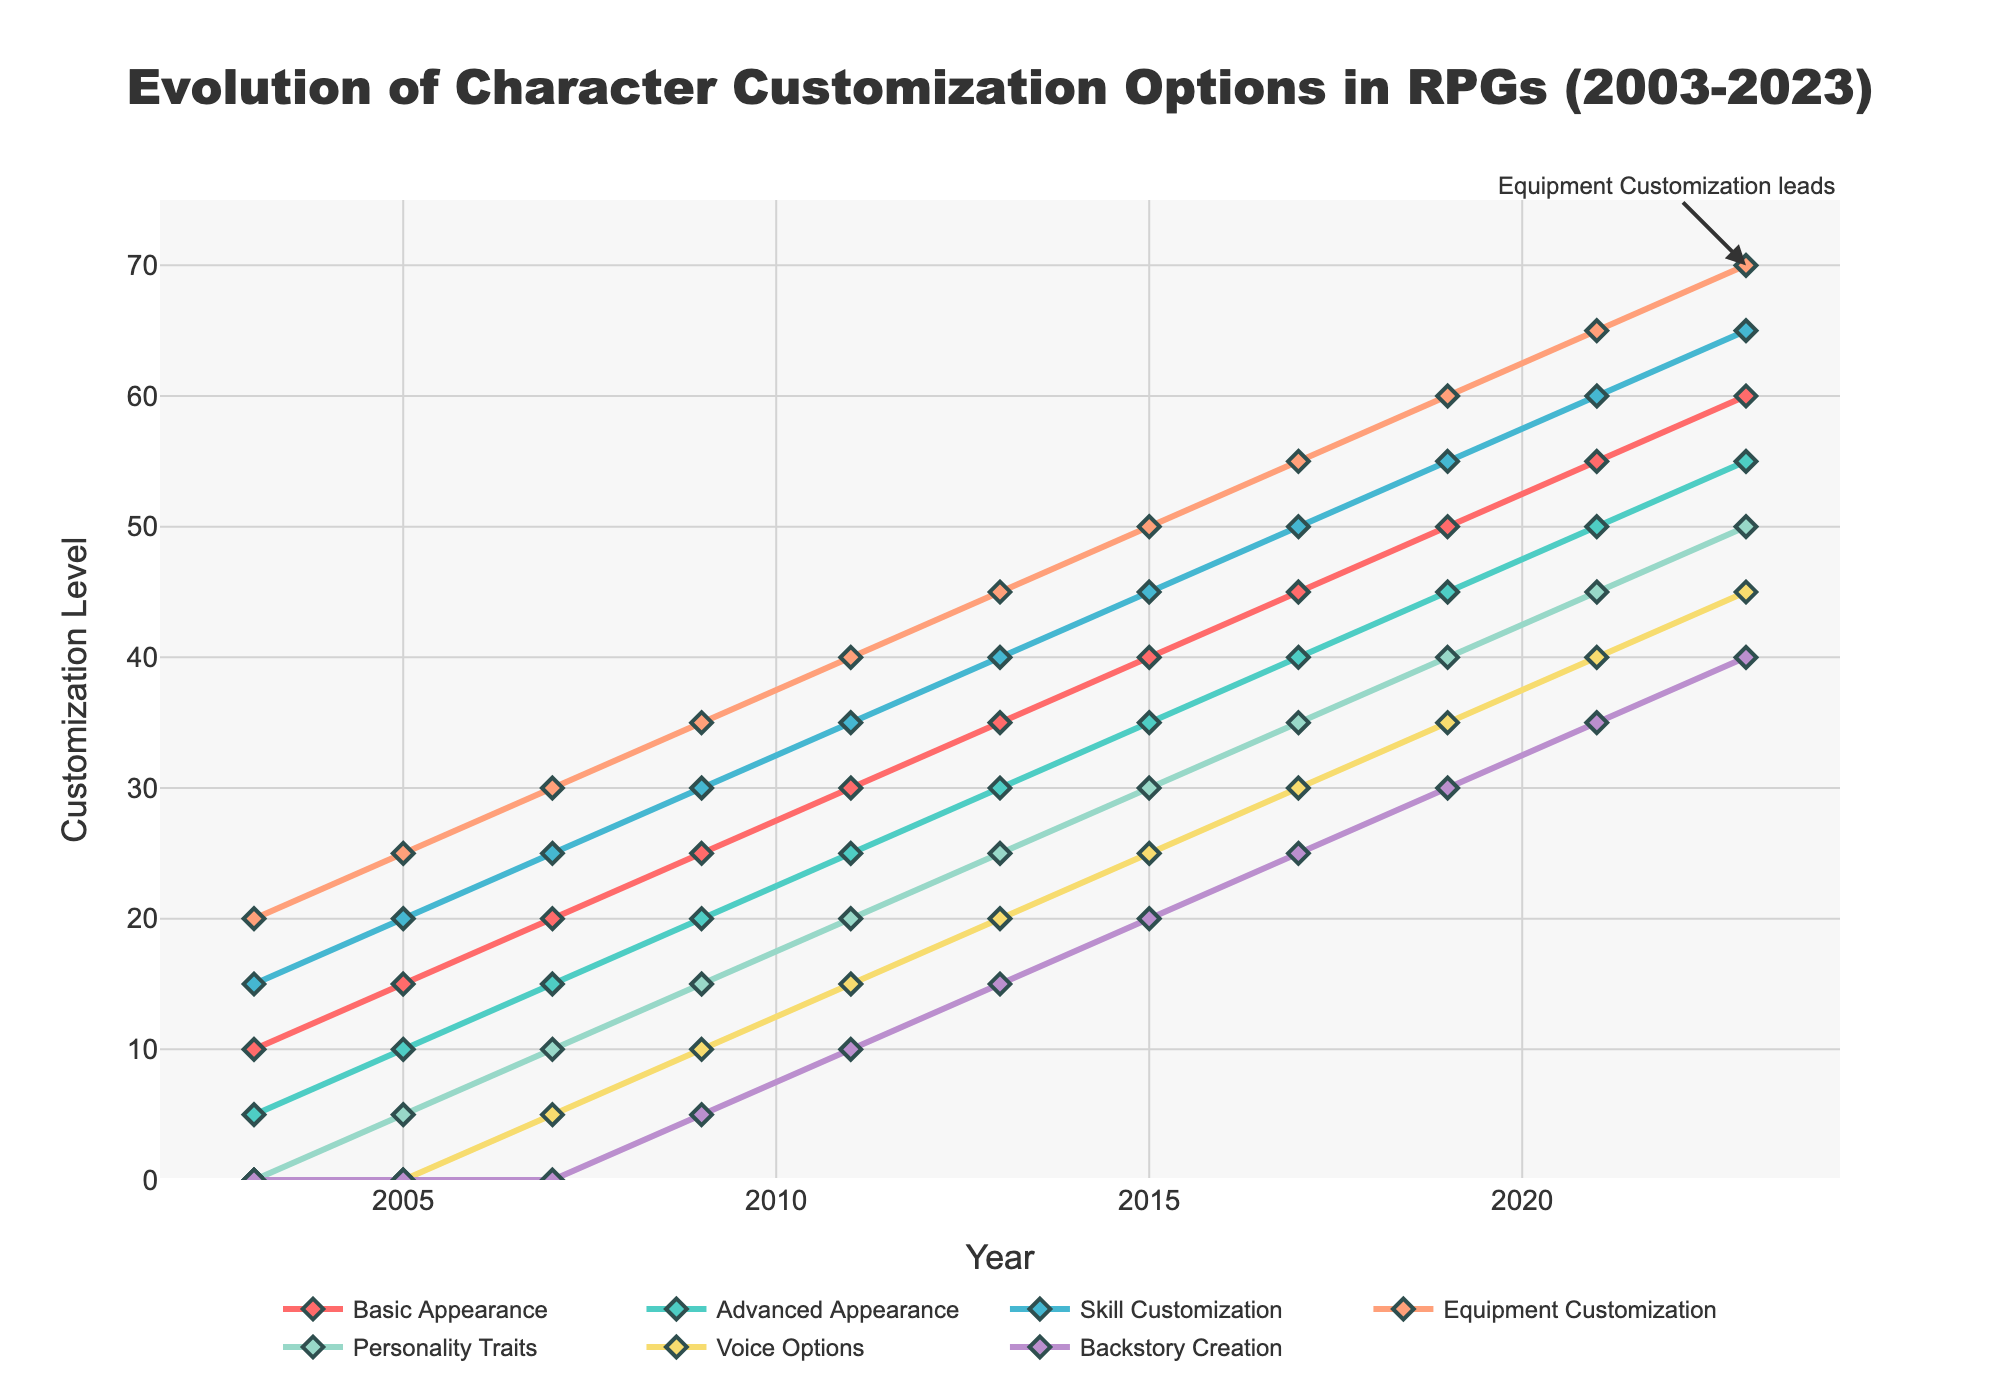What's the trend for Skill Customization from 2003 to 2023? To determine the trend, look at the line representing Skill Customization and observe its behavior over the years. It starts at 15 in 2003 and ends at 65 in 2023, showing a consistent increase.
Answer: Increasing Which customization option shows the most significant increase from 2003 to 2023? To find the most significant increase, compare the starting and ending values of each option from 2003 to 2023. Equipment Customization increased from 20 to 70, which is a 50-point increase, the highest among all options.
Answer: Equipment Customization In which year did Basic Appearance exceed 40 for the first time? Follow the Basic Appearance line and identify the year when it first goes above 40. This happens in 2017 when it reaches 45.
Answer: 2017 How many customization options were introduced after 2003? From the dataset, we can see that Personality Traits, Voice Options, and Backstory Creation are the options not present in 2003 and introduced in later years.
Answer: Three What is the difference between the levels of Advanced Appearance and Personality Traits in 2021? Look at the values for Advanced Appearance and Personality Traits in 2021. Advanced Appearance is 50 and Personality Traits is 45. The difference is 50 - 45.
Answer: 5 Which two customization options had equal values in 2009? Check the values for all customization options in 2009. Both Skill Customization and Equipment Customization have a level of 35.
Answer: Skill Customization and Equipment Customization Which customization option had the lowest value in 2023? Look at the values for all customization options in 2023 and identify the smallest one. Backstory Creation has the lowest value at 40.
Answer: Backstory Creation Compare the levels of Voice Options between 2015 and 2019. What do you find? Look at the points for Voice Options in 2015 (25) and 2019 (35). The value increases by 10 points.
Answer: The value increased by 10 What is the average customization level for Equipment Customization over the two decades? Sum the values of Equipment Customization for all years (20+25+30+35+40+45+50+55+60+65+70) and divide by the number of years (11).
Answer: 46.36 When did Backstory Creation start appearing, and what was its initial level? The line for Backstory Creation starts in the chart at the year 2009 with an initial level of 5.
Answer: 2009 and 5 